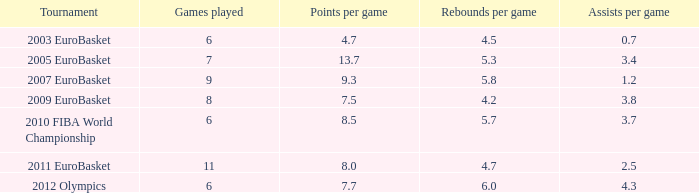In how many games is the average points per game 4.7? 6.0. 